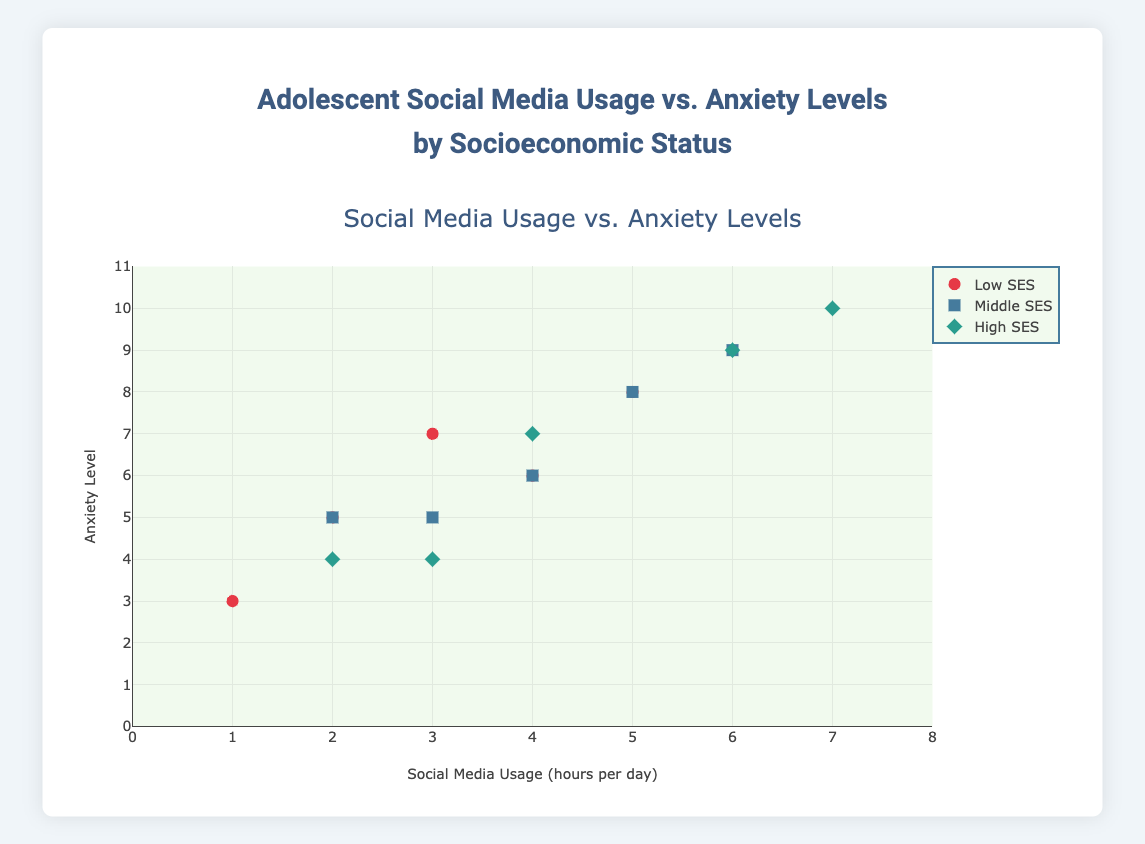what is the title of the plot? The title of the plot is prominently displayed at the top and reads "Adolescent Social Media Usage vs. Anxiety Levels by Socioeconomic Status".
Answer: Adolescent Social Media Usage vs. Anxiety Levels by Socioeconomic Status how many socioeconomic status groups are represented? There are three different colors and shapes for the markers in the scatter plot, each representing a distinct socioeconomic status group: Low, Middle, and High.
Answer: three which group shows the highest anxiety level? By observing the y-axis values, we see the highest anxiety level (10) is present in a data point marked with a diamond, which represents the High socioeconomic status group.
Answer: High what is the correlation between social media usage and anxiety levels in the Low socioeconomic status group? To determine the correlation, look at the trend of the markers under the Low socioeconomic status. We can see a general upward trend, indicating a positive correlation.
Answer: positive which group has more participants with higher social media usage (5+ hours per day)? To identify, count the number of data points above 5 hours per day on the x-axis for each group: Low (2 participants), Middle (2 participants), High (2 participants). They all tie with two participants each.
Answer: They all tie with two participants each what is the average anxiety level for the High socioeconomic status group? The anxiety levels for the High group are 9, 4, 10, 7, and 4. Their average is calculated as follows: (9 + 4 + 10 + 7 + 4) / 5 = 34 / 5 = 6.8.
Answer: 6.8 is there any Low socioeconomic status participant with an anxiety level lower than 4? By checking the y-axis values for the red circles representing Low SES, we find there's a point at (1, 3), indicating a participant with an anxiety level of 3.
Answer: Yes comparing the participant with the highest anxiety level, what is their social media usage and which socioeconomic status do they belong to? The highest anxiety level (10) is marked by a diamond at (7,10), indicating 7 hours of social media usage, belonging to the High socioeconomic status.
Answer: 7 hours, High how does the variability of anxiety levels differ between the Middle and High socioeconomic status groups? Middle SES (blue squares) has anxiety levels of 8, 6, 5, 9 and 9, showing lower variability with most values close together. High SES (green diamonds) ranges from 4 to 10, demonstrating higher variability.
Answer: High SES has higher variability what is the lowest social media usage observed and in which group does it fall? The lowest social media usage observed on the x-axis is 1 hour per day, represented by a red circle, belonging to the Low socioeconomic status.
Answer: 1 hour, Low which gender, if discernible, appears more frequently in the High socioeconomic status group? To answer, check gender inside the data set for High SES (P005, P006, P009, P012, P015): Female (P005, P009, P015) and Male (P006, P012). Females appear more frequently (3 vs. 2).
Answer: Female 